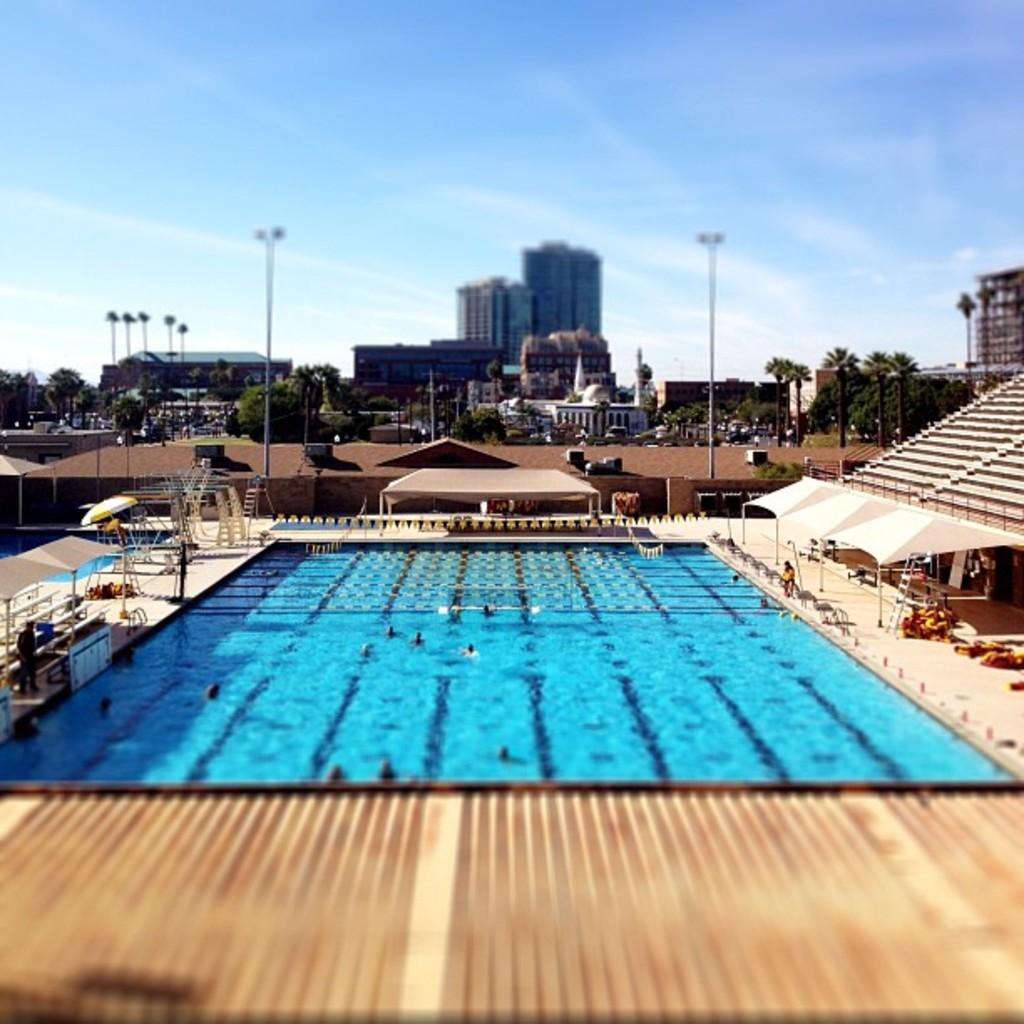What are the people in the image doing? The people in the image are swimming in a swimming pool. What can be seen in the background of the image? There are buildings, lamp posts, and trees in the background of the image. What type of tank can be seen in the image? There is no tank present in the image; it features people swimming in a swimming pool with buildings, lamp posts, and trees in the background. 